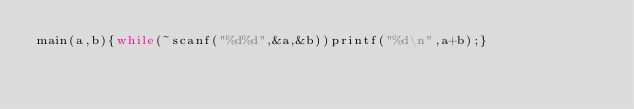<code> <loc_0><loc_0><loc_500><loc_500><_C_>main(a,b){while(~scanf("%d%d",&a,&b))printf("%d\n",a+b);}</code> 